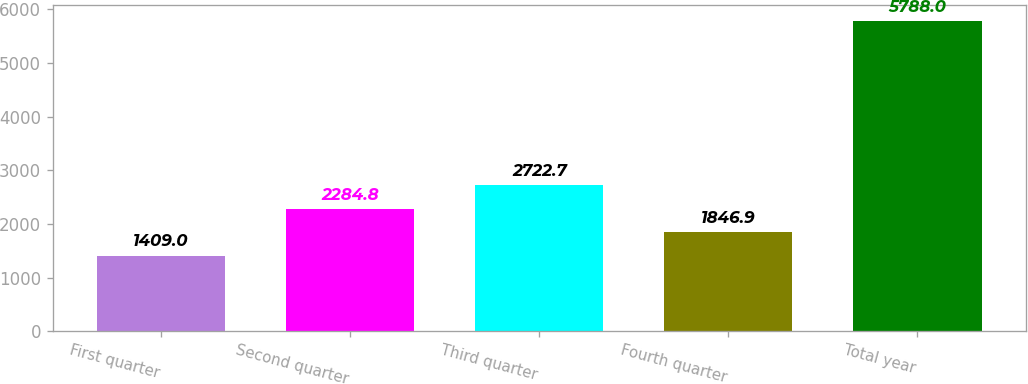Convert chart. <chart><loc_0><loc_0><loc_500><loc_500><bar_chart><fcel>First quarter<fcel>Second quarter<fcel>Third quarter<fcel>Fourth quarter<fcel>Total year<nl><fcel>1409<fcel>2284.8<fcel>2722.7<fcel>1846.9<fcel>5788<nl></chart> 